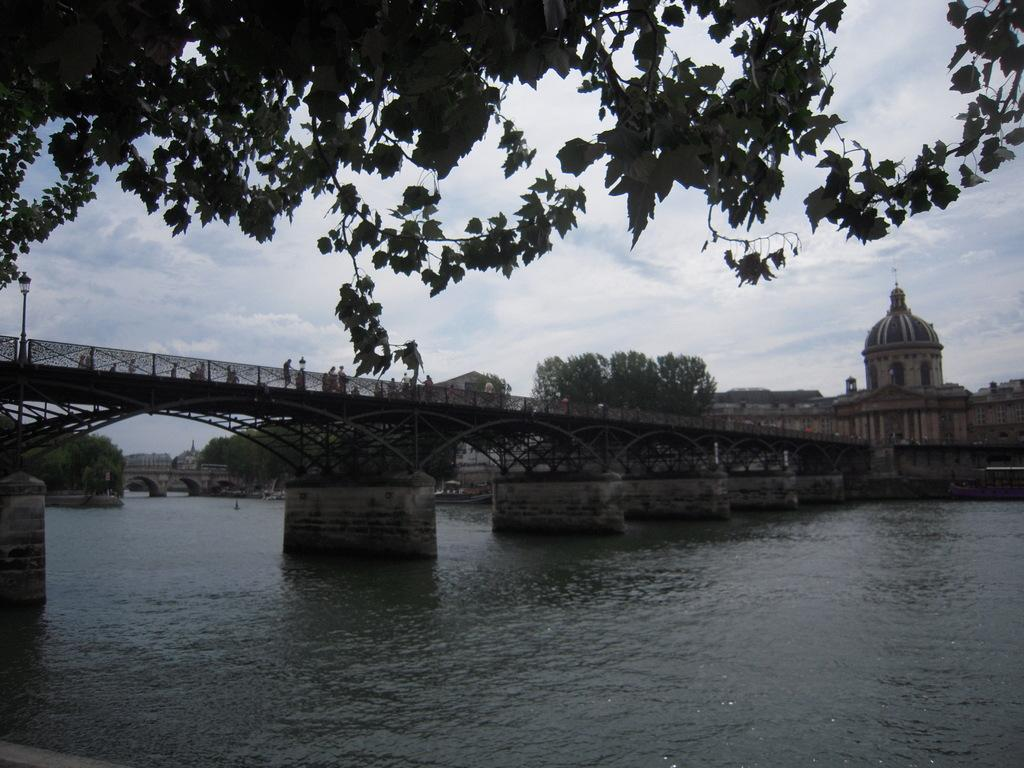What can be seen in the background of the image? There is a sky and a dome visible in the background of the image. What type of structures are present in the image? There are bridges, poles, and beams in the image. Who or what is present in the image? There are people in the image. What is the lighting like in the image? There are lights in the image. What natural elements can be seen in the image? There is water and trees visible in the image. What is the purpose of the children's education in the image? There are no children or any indication of education present in the image. 